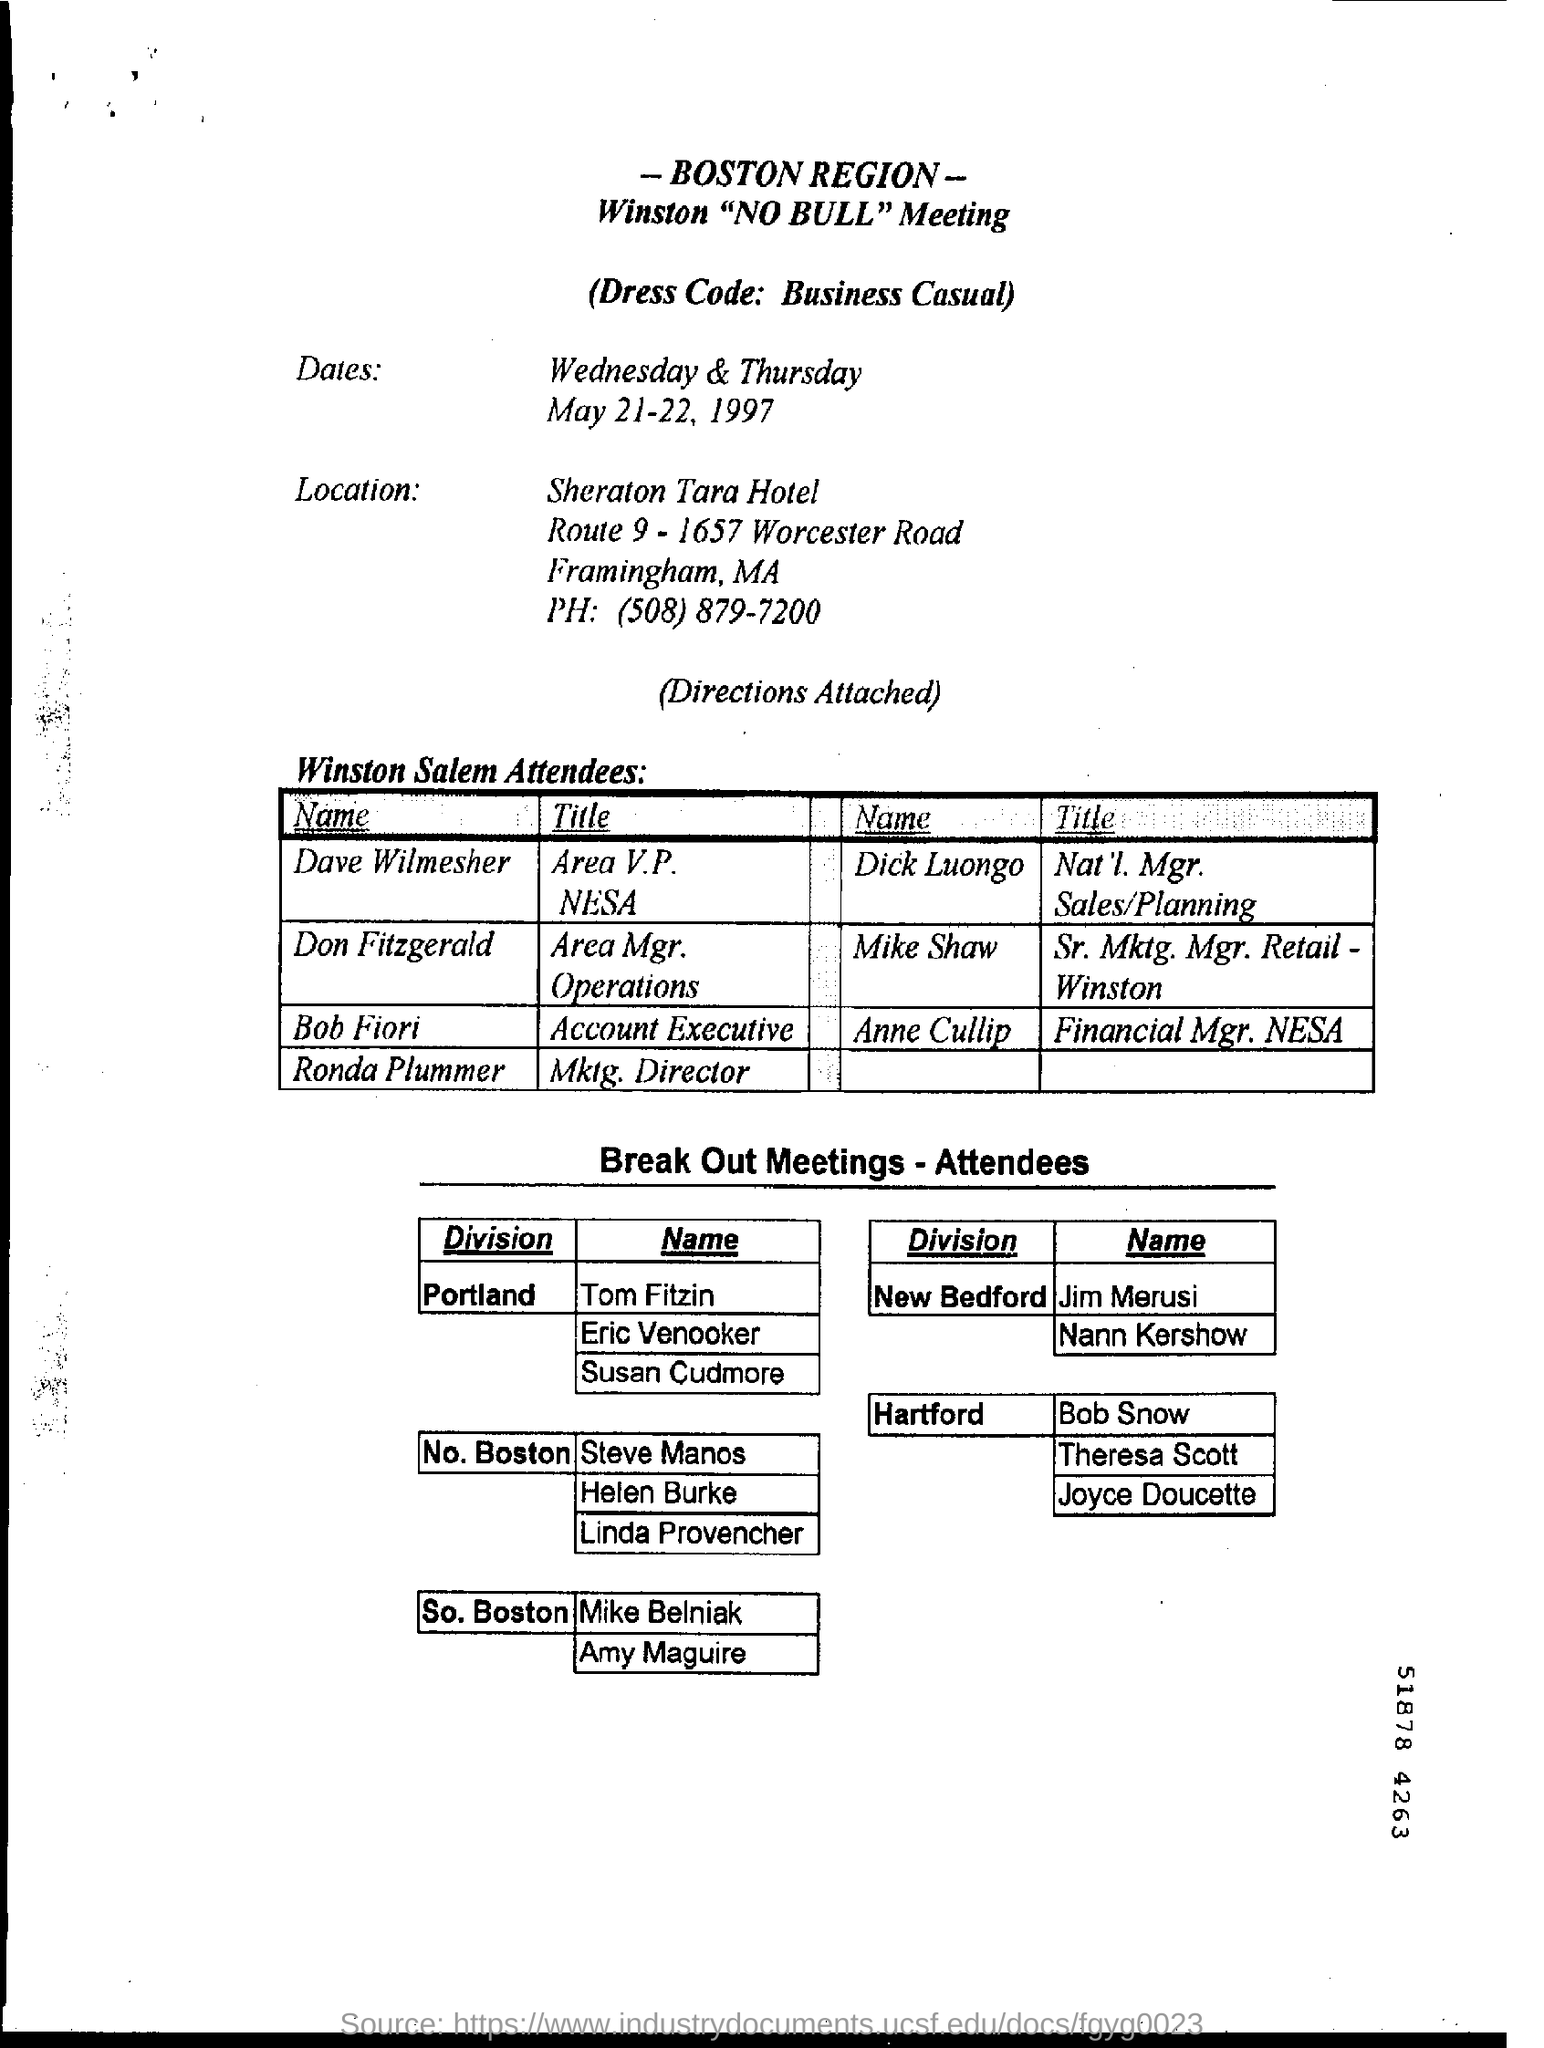What is digit shown at the bottom right corner?
Ensure brevity in your answer.  51878 4263. What is the dress code for the meeting?
Ensure brevity in your answer.  Business Casual. 